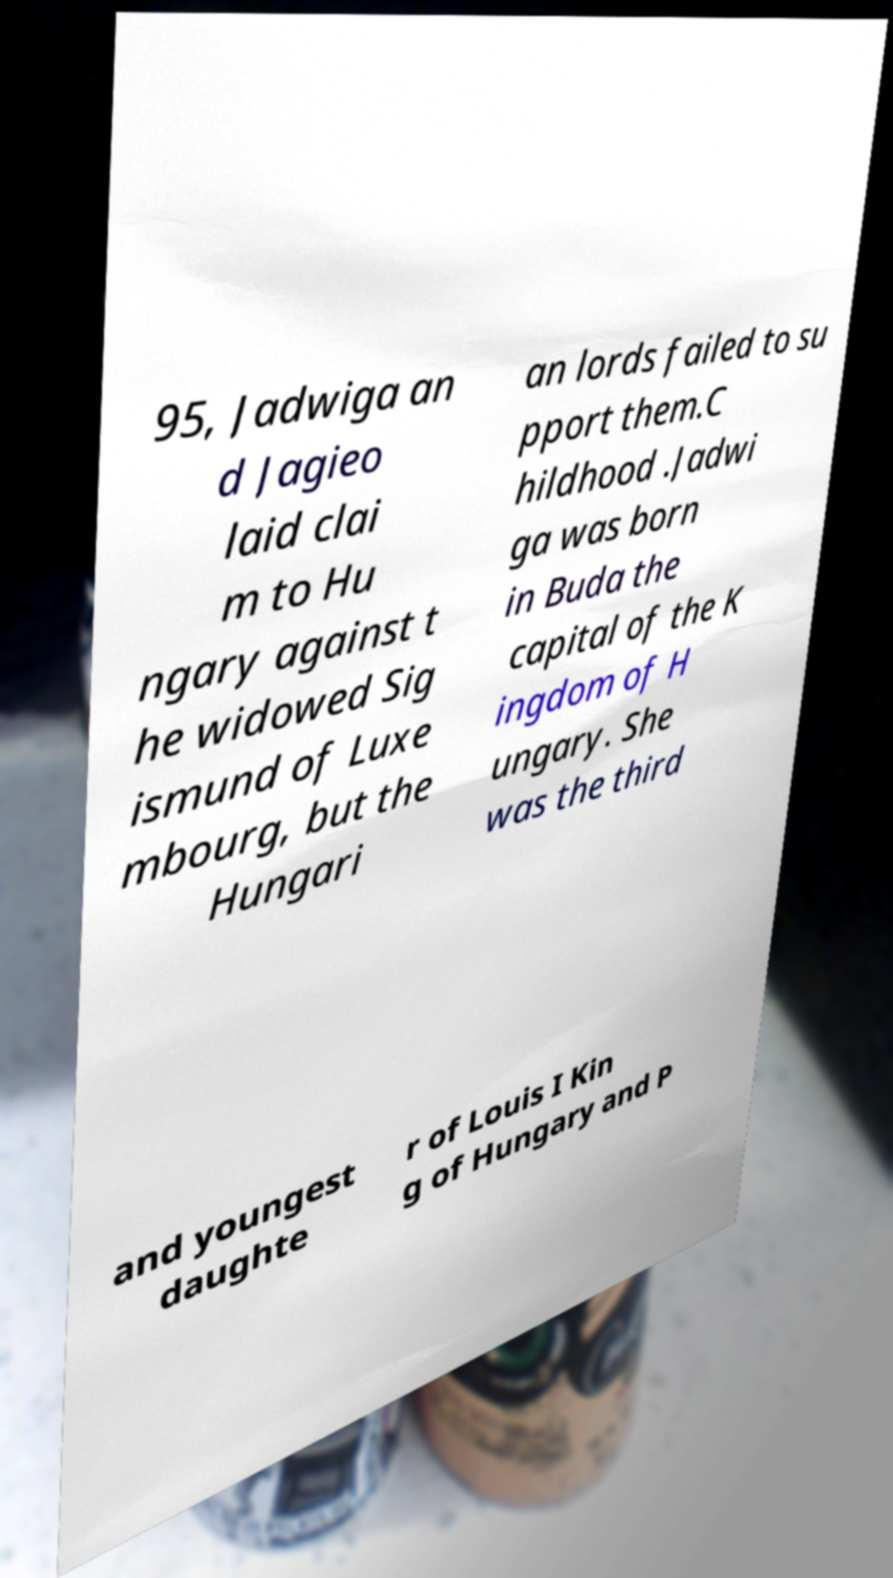Can you accurately transcribe the text from the provided image for me? 95, Jadwiga an d Jagieo laid clai m to Hu ngary against t he widowed Sig ismund of Luxe mbourg, but the Hungari an lords failed to su pport them.C hildhood .Jadwi ga was born in Buda the capital of the K ingdom of H ungary. She was the third and youngest daughte r of Louis I Kin g of Hungary and P 